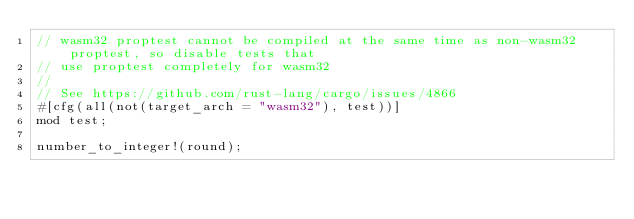<code> <loc_0><loc_0><loc_500><loc_500><_Rust_>// wasm32 proptest cannot be compiled at the same time as non-wasm32 proptest, so disable tests that
// use proptest completely for wasm32
//
// See https://github.com/rust-lang/cargo/issues/4866
#[cfg(all(not(target_arch = "wasm32"), test))]
mod test;

number_to_integer!(round);
</code> 